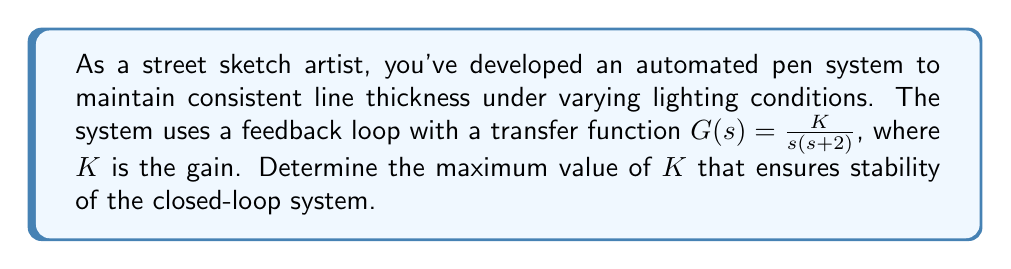Solve this math problem. To analyze the stability of this feedback system, we'll use the Routh-Hurwitz stability criterion. Here's the step-by-step process:

1) First, we need to determine the closed-loop transfer function. For a unity feedback system:

   $$T(s) = \frac{G(s)}{1 + G(s)} = \frac{\frac{K}{s(s+2)}}{1 + \frac{K}{s(s+2)}}$$

2) Simplify the closed-loop transfer function:

   $$T(s) = \frac{K}{s^2 + 2s + K}$$

3) The characteristic equation is:

   $$s^2 + 2s + K = 0$$

4) Now, we'll construct the Routh array:

   $$\begin{array}{c|c}
   s^2 & 1 & K \\
   s^1 & 2 & 0 \\
   s^0 & K & 0
   \end{array}$$

5) For stability, all elements in the first column must be positive. We already know that 1 > 0 and 2 > 0. For the last element:

   $K > 0$

6) There's no condition on the second row as it's always positive (2 > 0).

7) Therefore, the only condition for stability is $K > 0$.

8) However, we need to find the maximum value of $K$. As $K$ increases, the system will eventually become unstable. This occurs when the system has purely imaginary roots, i.e., when it's on the verge of instability.

9) For this to happen, the last row of the Routh array should become zero:

   $K - \frac{K}{2} \cdot 0 = 0$

   This is always true, regardless of $K$.

10) In this case, we need to look at the auxiliary equation formed by the coefficients of the row above the zero row:

    $s^2 + K = 0$

11) For marginal stability, $K = \omega^2$, where $\omega$ is the frequency of oscillation.

12) Substituting this into the characteristic equation:

    $s^2 + 2s + \omega^2 = 0$

13) For purely imaginary roots, $s = j\omega$. Substituting:

    $-\omega^2 + 2j\omega + \omega^2 = 0$

14) Equating the imaginary part to zero:

    $2\omega = 0$
    $\omega = 0$

15) This means the system never actually becomes unstable for any finite positive value of $K$.
Answer: The maximum value of $K$ that ensures stability is $K \to \infty$. The system is stable for all positive values of $K$. 